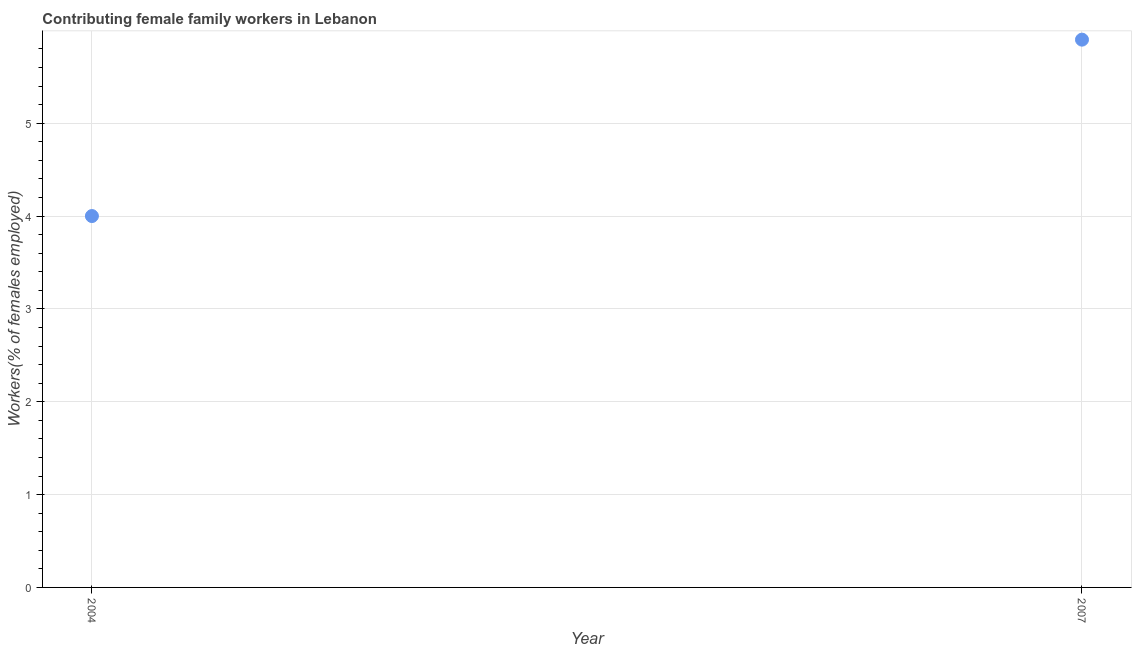What is the contributing female family workers in 2007?
Your answer should be compact. 5.9. Across all years, what is the maximum contributing female family workers?
Provide a short and direct response. 5.9. What is the sum of the contributing female family workers?
Offer a very short reply. 9.9. What is the difference between the contributing female family workers in 2004 and 2007?
Your answer should be very brief. -1.9. What is the average contributing female family workers per year?
Your response must be concise. 4.95. What is the median contributing female family workers?
Your answer should be compact. 4.95. In how many years, is the contributing female family workers greater than 1 %?
Give a very brief answer. 2. What is the ratio of the contributing female family workers in 2004 to that in 2007?
Keep it short and to the point. 0.68. Is the contributing female family workers in 2004 less than that in 2007?
Offer a very short reply. Yes. How many years are there in the graph?
Your response must be concise. 2. What is the difference between two consecutive major ticks on the Y-axis?
Offer a very short reply. 1. Does the graph contain any zero values?
Keep it short and to the point. No. What is the title of the graph?
Keep it short and to the point. Contributing female family workers in Lebanon. What is the label or title of the Y-axis?
Provide a succinct answer. Workers(% of females employed). What is the Workers(% of females employed) in 2007?
Keep it short and to the point. 5.9. What is the ratio of the Workers(% of females employed) in 2004 to that in 2007?
Your response must be concise. 0.68. 